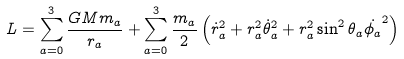<formula> <loc_0><loc_0><loc_500><loc_500>L = \sum _ { a = 0 } ^ { 3 } \frac { G M m _ { a } } { r _ { a } } + \sum _ { a = 0 } ^ { 3 } \frac { m _ { a } } { 2 } \left ( \dot { r } _ { a } ^ { 2 } + r _ { a } ^ { 2 } \dot { \theta } _ { a } ^ { 2 } + r _ { a } ^ { 2 } \sin ^ { 2 } \theta _ { a } \dot { \phi _ { a } } ^ { 2 } \right )</formula> 